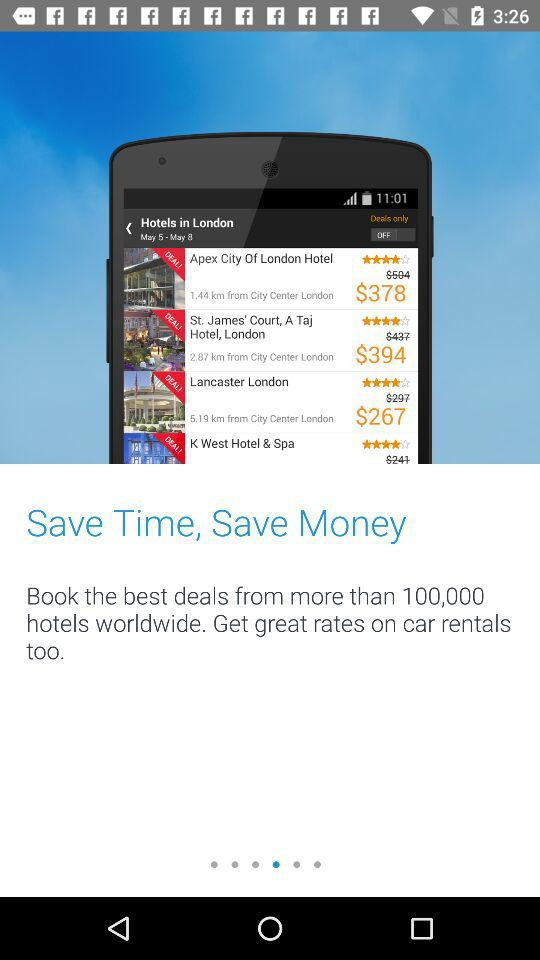What is the cost of Lancaster London? The cost of Lancaster London is $267. 